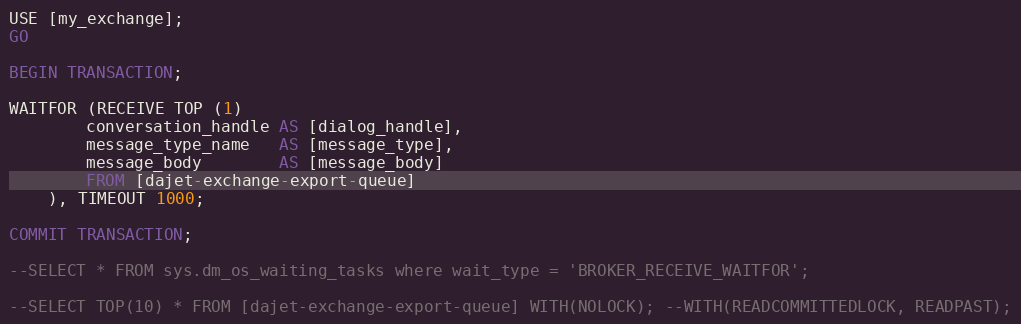<code> <loc_0><loc_0><loc_500><loc_500><_SQL_>USE [my_exchange];
GO

BEGIN TRANSACTION;

WAITFOR (RECEIVE TOP (1)
		conversation_handle AS [dialog_handle],
		message_type_name   AS [message_type],
		message_body        AS [message_body]
		FROM [dajet-exchange-export-queue]
	), TIMEOUT 1000;

COMMIT TRANSACTION;

--SELECT * FROM sys.dm_os_waiting_tasks where wait_type = 'BROKER_RECEIVE_WAITFOR';

--SELECT TOP(10) * FROM [dajet-exchange-export-queue] WITH(NOLOCK); --WITH(READCOMMITTEDLOCK, READPAST);</code> 